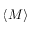<formula> <loc_0><loc_0><loc_500><loc_500>\langle M \rangle</formula> 